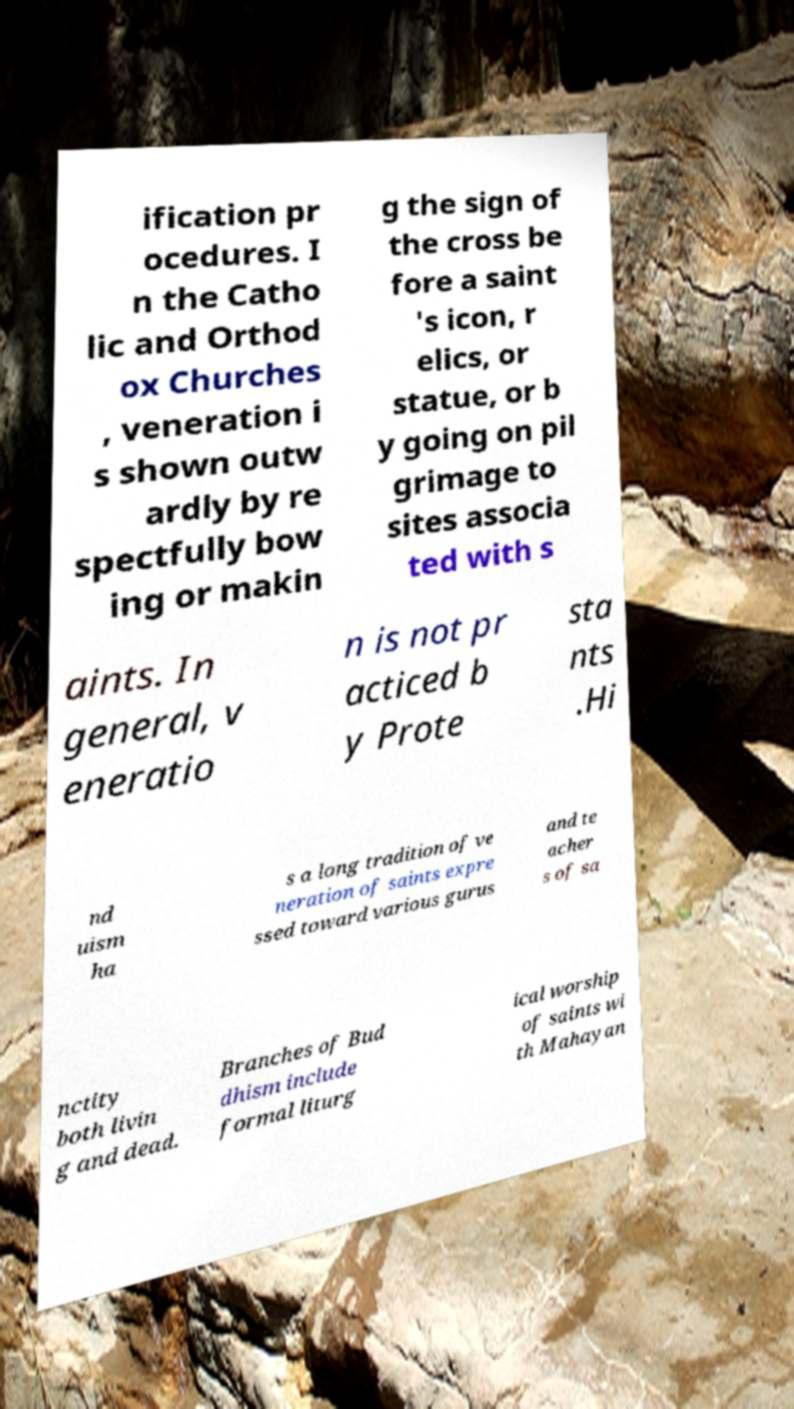Can you accurately transcribe the text from the provided image for me? ification pr ocedures. I n the Catho lic and Orthod ox Churches , veneration i s shown outw ardly by re spectfully bow ing or makin g the sign of the cross be fore a saint 's icon, r elics, or statue, or b y going on pil grimage to sites associa ted with s aints. In general, v eneratio n is not pr acticed b y Prote sta nts .Hi nd uism ha s a long tradition of ve neration of saints expre ssed toward various gurus and te acher s of sa nctity both livin g and dead. Branches of Bud dhism include formal liturg ical worship of saints wi th Mahayan 